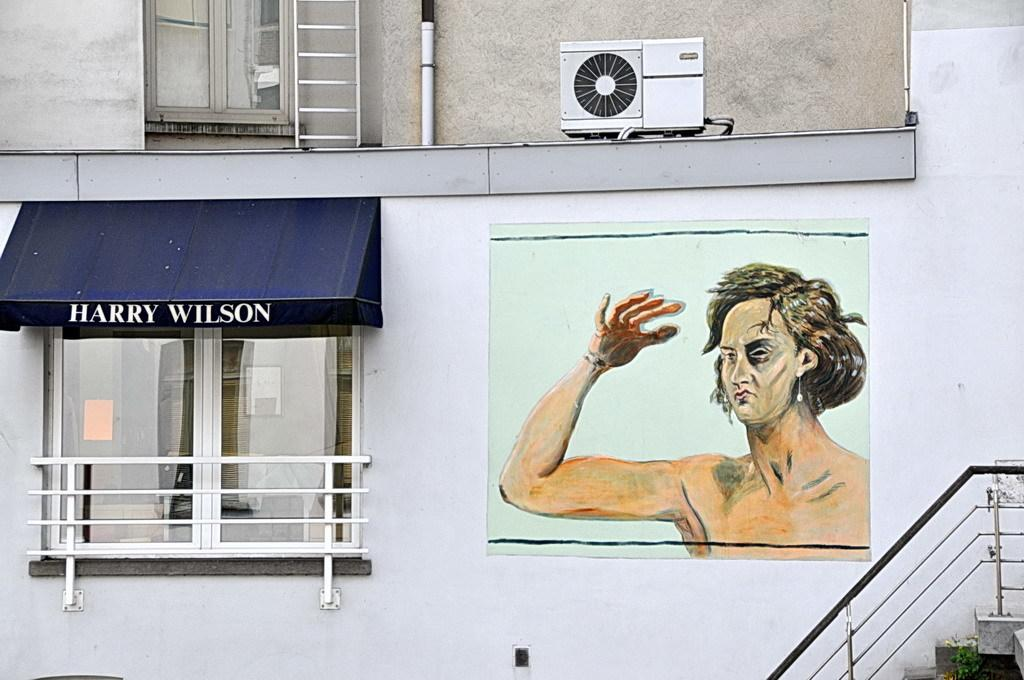<image>
Describe the image concisely. a window for HARRY Wilson next to a painting of a man 